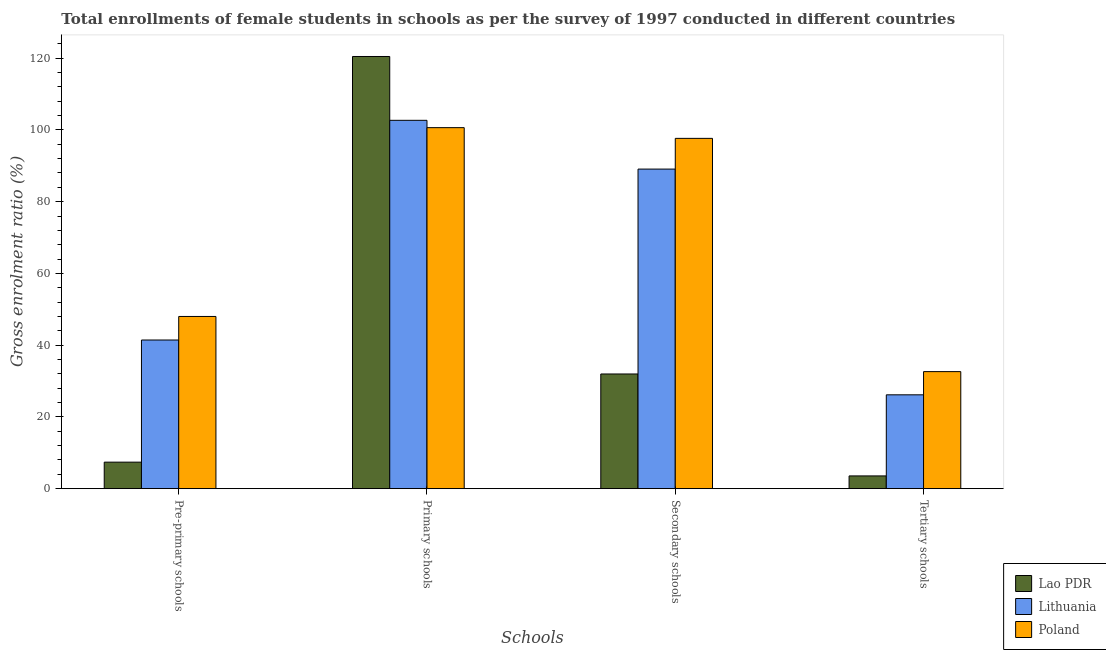How many bars are there on the 3rd tick from the left?
Give a very brief answer. 3. How many bars are there on the 2nd tick from the right?
Ensure brevity in your answer.  3. What is the label of the 1st group of bars from the left?
Your answer should be very brief. Pre-primary schools. What is the gross enrolment ratio(female) in primary schools in Lithuania?
Provide a short and direct response. 102.67. Across all countries, what is the maximum gross enrolment ratio(female) in primary schools?
Your answer should be compact. 120.47. Across all countries, what is the minimum gross enrolment ratio(female) in tertiary schools?
Make the answer very short. 3.56. In which country was the gross enrolment ratio(female) in pre-primary schools minimum?
Give a very brief answer. Lao PDR. What is the total gross enrolment ratio(female) in secondary schools in the graph?
Your answer should be very brief. 218.7. What is the difference between the gross enrolment ratio(female) in primary schools in Lithuania and that in Lao PDR?
Make the answer very short. -17.79. What is the difference between the gross enrolment ratio(female) in tertiary schools in Lithuania and the gross enrolment ratio(female) in pre-primary schools in Lao PDR?
Provide a short and direct response. 18.77. What is the average gross enrolment ratio(female) in tertiary schools per country?
Make the answer very short. 20.78. What is the difference between the gross enrolment ratio(female) in tertiary schools and gross enrolment ratio(female) in primary schools in Lao PDR?
Give a very brief answer. -116.91. What is the ratio of the gross enrolment ratio(female) in tertiary schools in Lao PDR to that in Lithuania?
Provide a short and direct response. 0.14. Is the gross enrolment ratio(female) in pre-primary schools in Poland less than that in Lao PDR?
Make the answer very short. No. What is the difference between the highest and the second highest gross enrolment ratio(female) in secondary schools?
Your answer should be very brief. 8.56. What is the difference between the highest and the lowest gross enrolment ratio(female) in pre-primary schools?
Your answer should be compact. 40.61. In how many countries, is the gross enrolment ratio(female) in pre-primary schools greater than the average gross enrolment ratio(female) in pre-primary schools taken over all countries?
Your response must be concise. 2. Is it the case that in every country, the sum of the gross enrolment ratio(female) in primary schools and gross enrolment ratio(female) in tertiary schools is greater than the sum of gross enrolment ratio(female) in secondary schools and gross enrolment ratio(female) in pre-primary schools?
Keep it short and to the point. Yes. What does the 2nd bar from the left in Secondary schools represents?
Your answer should be compact. Lithuania. What does the 2nd bar from the right in Secondary schools represents?
Your response must be concise. Lithuania. Are all the bars in the graph horizontal?
Your answer should be compact. No. How many countries are there in the graph?
Provide a short and direct response. 3. What is the difference between two consecutive major ticks on the Y-axis?
Ensure brevity in your answer.  20. Does the graph contain grids?
Your answer should be very brief. No. What is the title of the graph?
Provide a short and direct response. Total enrollments of female students in schools as per the survey of 1997 conducted in different countries. What is the label or title of the X-axis?
Provide a short and direct response. Schools. What is the label or title of the Y-axis?
Offer a terse response. Gross enrolment ratio (%). What is the Gross enrolment ratio (%) in Lao PDR in Pre-primary schools?
Make the answer very short. 7.39. What is the Gross enrolment ratio (%) of Lithuania in Pre-primary schools?
Give a very brief answer. 41.44. What is the Gross enrolment ratio (%) of Poland in Pre-primary schools?
Offer a terse response. 48. What is the Gross enrolment ratio (%) of Lao PDR in Primary schools?
Your answer should be very brief. 120.47. What is the Gross enrolment ratio (%) in Lithuania in Primary schools?
Provide a succinct answer. 102.67. What is the Gross enrolment ratio (%) in Poland in Primary schools?
Offer a terse response. 100.63. What is the Gross enrolment ratio (%) of Lao PDR in Secondary schools?
Keep it short and to the point. 31.97. What is the Gross enrolment ratio (%) in Lithuania in Secondary schools?
Provide a short and direct response. 89.08. What is the Gross enrolment ratio (%) of Poland in Secondary schools?
Give a very brief answer. 97.65. What is the Gross enrolment ratio (%) in Lao PDR in Tertiary schools?
Your answer should be compact. 3.56. What is the Gross enrolment ratio (%) in Lithuania in Tertiary schools?
Make the answer very short. 26.16. What is the Gross enrolment ratio (%) in Poland in Tertiary schools?
Your answer should be compact. 32.63. Across all Schools, what is the maximum Gross enrolment ratio (%) in Lao PDR?
Keep it short and to the point. 120.47. Across all Schools, what is the maximum Gross enrolment ratio (%) in Lithuania?
Provide a short and direct response. 102.67. Across all Schools, what is the maximum Gross enrolment ratio (%) of Poland?
Your answer should be very brief. 100.63. Across all Schools, what is the minimum Gross enrolment ratio (%) in Lao PDR?
Ensure brevity in your answer.  3.56. Across all Schools, what is the minimum Gross enrolment ratio (%) of Lithuania?
Your answer should be compact. 26.16. Across all Schools, what is the minimum Gross enrolment ratio (%) of Poland?
Your response must be concise. 32.63. What is the total Gross enrolment ratio (%) in Lao PDR in the graph?
Provide a succinct answer. 163.39. What is the total Gross enrolment ratio (%) of Lithuania in the graph?
Provide a succinct answer. 259.36. What is the total Gross enrolment ratio (%) in Poland in the graph?
Offer a terse response. 278.91. What is the difference between the Gross enrolment ratio (%) of Lao PDR in Pre-primary schools and that in Primary schools?
Make the answer very short. -113.08. What is the difference between the Gross enrolment ratio (%) of Lithuania in Pre-primary schools and that in Primary schools?
Keep it short and to the point. -61.23. What is the difference between the Gross enrolment ratio (%) in Poland in Pre-primary schools and that in Primary schools?
Provide a short and direct response. -52.63. What is the difference between the Gross enrolment ratio (%) in Lao PDR in Pre-primary schools and that in Secondary schools?
Your response must be concise. -24.58. What is the difference between the Gross enrolment ratio (%) in Lithuania in Pre-primary schools and that in Secondary schools?
Offer a terse response. -47.64. What is the difference between the Gross enrolment ratio (%) of Poland in Pre-primary schools and that in Secondary schools?
Offer a terse response. -49.64. What is the difference between the Gross enrolment ratio (%) in Lao PDR in Pre-primary schools and that in Tertiary schools?
Your answer should be very brief. 3.84. What is the difference between the Gross enrolment ratio (%) in Lithuania in Pre-primary schools and that in Tertiary schools?
Offer a very short reply. 15.28. What is the difference between the Gross enrolment ratio (%) of Poland in Pre-primary schools and that in Tertiary schools?
Make the answer very short. 15.37. What is the difference between the Gross enrolment ratio (%) in Lao PDR in Primary schools and that in Secondary schools?
Your response must be concise. 88.5. What is the difference between the Gross enrolment ratio (%) in Lithuania in Primary schools and that in Secondary schools?
Make the answer very short. 13.59. What is the difference between the Gross enrolment ratio (%) of Poland in Primary schools and that in Secondary schools?
Ensure brevity in your answer.  2.98. What is the difference between the Gross enrolment ratio (%) in Lao PDR in Primary schools and that in Tertiary schools?
Provide a succinct answer. 116.91. What is the difference between the Gross enrolment ratio (%) of Lithuania in Primary schools and that in Tertiary schools?
Make the answer very short. 76.51. What is the difference between the Gross enrolment ratio (%) in Poland in Primary schools and that in Tertiary schools?
Your response must be concise. 68. What is the difference between the Gross enrolment ratio (%) in Lao PDR in Secondary schools and that in Tertiary schools?
Provide a short and direct response. 28.42. What is the difference between the Gross enrolment ratio (%) of Lithuania in Secondary schools and that in Tertiary schools?
Your answer should be very brief. 62.92. What is the difference between the Gross enrolment ratio (%) in Poland in Secondary schools and that in Tertiary schools?
Keep it short and to the point. 65.02. What is the difference between the Gross enrolment ratio (%) in Lao PDR in Pre-primary schools and the Gross enrolment ratio (%) in Lithuania in Primary schools?
Your answer should be compact. -95.28. What is the difference between the Gross enrolment ratio (%) in Lao PDR in Pre-primary schools and the Gross enrolment ratio (%) in Poland in Primary schools?
Make the answer very short. -93.24. What is the difference between the Gross enrolment ratio (%) in Lithuania in Pre-primary schools and the Gross enrolment ratio (%) in Poland in Primary schools?
Your response must be concise. -59.19. What is the difference between the Gross enrolment ratio (%) of Lao PDR in Pre-primary schools and the Gross enrolment ratio (%) of Lithuania in Secondary schools?
Your answer should be compact. -81.69. What is the difference between the Gross enrolment ratio (%) in Lao PDR in Pre-primary schools and the Gross enrolment ratio (%) in Poland in Secondary schools?
Ensure brevity in your answer.  -90.25. What is the difference between the Gross enrolment ratio (%) in Lithuania in Pre-primary schools and the Gross enrolment ratio (%) in Poland in Secondary schools?
Give a very brief answer. -56.21. What is the difference between the Gross enrolment ratio (%) in Lao PDR in Pre-primary schools and the Gross enrolment ratio (%) in Lithuania in Tertiary schools?
Ensure brevity in your answer.  -18.77. What is the difference between the Gross enrolment ratio (%) in Lao PDR in Pre-primary schools and the Gross enrolment ratio (%) in Poland in Tertiary schools?
Offer a very short reply. -25.24. What is the difference between the Gross enrolment ratio (%) in Lithuania in Pre-primary schools and the Gross enrolment ratio (%) in Poland in Tertiary schools?
Ensure brevity in your answer.  8.81. What is the difference between the Gross enrolment ratio (%) of Lao PDR in Primary schools and the Gross enrolment ratio (%) of Lithuania in Secondary schools?
Your response must be concise. 31.39. What is the difference between the Gross enrolment ratio (%) of Lao PDR in Primary schools and the Gross enrolment ratio (%) of Poland in Secondary schools?
Give a very brief answer. 22.82. What is the difference between the Gross enrolment ratio (%) of Lithuania in Primary schools and the Gross enrolment ratio (%) of Poland in Secondary schools?
Provide a short and direct response. 5.03. What is the difference between the Gross enrolment ratio (%) in Lao PDR in Primary schools and the Gross enrolment ratio (%) in Lithuania in Tertiary schools?
Ensure brevity in your answer.  94.31. What is the difference between the Gross enrolment ratio (%) of Lao PDR in Primary schools and the Gross enrolment ratio (%) of Poland in Tertiary schools?
Offer a terse response. 87.84. What is the difference between the Gross enrolment ratio (%) of Lithuania in Primary schools and the Gross enrolment ratio (%) of Poland in Tertiary schools?
Ensure brevity in your answer.  70.04. What is the difference between the Gross enrolment ratio (%) of Lao PDR in Secondary schools and the Gross enrolment ratio (%) of Lithuania in Tertiary schools?
Offer a terse response. 5.81. What is the difference between the Gross enrolment ratio (%) in Lao PDR in Secondary schools and the Gross enrolment ratio (%) in Poland in Tertiary schools?
Your response must be concise. -0.66. What is the difference between the Gross enrolment ratio (%) in Lithuania in Secondary schools and the Gross enrolment ratio (%) in Poland in Tertiary schools?
Keep it short and to the point. 56.45. What is the average Gross enrolment ratio (%) of Lao PDR per Schools?
Give a very brief answer. 40.85. What is the average Gross enrolment ratio (%) of Lithuania per Schools?
Give a very brief answer. 64.84. What is the average Gross enrolment ratio (%) of Poland per Schools?
Your answer should be very brief. 69.73. What is the difference between the Gross enrolment ratio (%) in Lao PDR and Gross enrolment ratio (%) in Lithuania in Pre-primary schools?
Provide a succinct answer. -34.05. What is the difference between the Gross enrolment ratio (%) of Lao PDR and Gross enrolment ratio (%) of Poland in Pre-primary schools?
Make the answer very short. -40.61. What is the difference between the Gross enrolment ratio (%) in Lithuania and Gross enrolment ratio (%) in Poland in Pre-primary schools?
Make the answer very short. -6.56. What is the difference between the Gross enrolment ratio (%) of Lao PDR and Gross enrolment ratio (%) of Lithuania in Primary schools?
Make the answer very short. 17.8. What is the difference between the Gross enrolment ratio (%) of Lao PDR and Gross enrolment ratio (%) of Poland in Primary schools?
Offer a terse response. 19.84. What is the difference between the Gross enrolment ratio (%) of Lithuania and Gross enrolment ratio (%) of Poland in Primary schools?
Provide a short and direct response. 2.04. What is the difference between the Gross enrolment ratio (%) in Lao PDR and Gross enrolment ratio (%) in Lithuania in Secondary schools?
Your answer should be compact. -57.11. What is the difference between the Gross enrolment ratio (%) of Lao PDR and Gross enrolment ratio (%) of Poland in Secondary schools?
Your response must be concise. -65.68. What is the difference between the Gross enrolment ratio (%) in Lithuania and Gross enrolment ratio (%) in Poland in Secondary schools?
Ensure brevity in your answer.  -8.56. What is the difference between the Gross enrolment ratio (%) of Lao PDR and Gross enrolment ratio (%) of Lithuania in Tertiary schools?
Make the answer very short. -22.61. What is the difference between the Gross enrolment ratio (%) of Lao PDR and Gross enrolment ratio (%) of Poland in Tertiary schools?
Ensure brevity in your answer.  -29.08. What is the difference between the Gross enrolment ratio (%) in Lithuania and Gross enrolment ratio (%) in Poland in Tertiary schools?
Provide a short and direct response. -6.47. What is the ratio of the Gross enrolment ratio (%) of Lao PDR in Pre-primary schools to that in Primary schools?
Provide a succinct answer. 0.06. What is the ratio of the Gross enrolment ratio (%) of Lithuania in Pre-primary schools to that in Primary schools?
Give a very brief answer. 0.4. What is the ratio of the Gross enrolment ratio (%) in Poland in Pre-primary schools to that in Primary schools?
Your answer should be very brief. 0.48. What is the ratio of the Gross enrolment ratio (%) of Lao PDR in Pre-primary schools to that in Secondary schools?
Provide a succinct answer. 0.23. What is the ratio of the Gross enrolment ratio (%) of Lithuania in Pre-primary schools to that in Secondary schools?
Make the answer very short. 0.47. What is the ratio of the Gross enrolment ratio (%) in Poland in Pre-primary schools to that in Secondary schools?
Your answer should be very brief. 0.49. What is the ratio of the Gross enrolment ratio (%) in Lao PDR in Pre-primary schools to that in Tertiary schools?
Offer a very short reply. 2.08. What is the ratio of the Gross enrolment ratio (%) in Lithuania in Pre-primary schools to that in Tertiary schools?
Offer a very short reply. 1.58. What is the ratio of the Gross enrolment ratio (%) in Poland in Pre-primary schools to that in Tertiary schools?
Offer a terse response. 1.47. What is the ratio of the Gross enrolment ratio (%) of Lao PDR in Primary schools to that in Secondary schools?
Your answer should be very brief. 3.77. What is the ratio of the Gross enrolment ratio (%) of Lithuania in Primary schools to that in Secondary schools?
Give a very brief answer. 1.15. What is the ratio of the Gross enrolment ratio (%) in Poland in Primary schools to that in Secondary schools?
Provide a short and direct response. 1.03. What is the ratio of the Gross enrolment ratio (%) of Lao PDR in Primary schools to that in Tertiary schools?
Provide a succinct answer. 33.88. What is the ratio of the Gross enrolment ratio (%) of Lithuania in Primary schools to that in Tertiary schools?
Your answer should be compact. 3.92. What is the ratio of the Gross enrolment ratio (%) in Poland in Primary schools to that in Tertiary schools?
Provide a short and direct response. 3.08. What is the ratio of the Gross enrolment ratio (%) in Lao PDR in Secondary schools to that in Tertiary schools?
Provide a short and direct response. 8.99. What is the ratio of the Gross enrolment ratio (%) in Lithuania in Secondary schools to that in Tertiary schools?
Your response must be concise. 3.4. What is the ratio of the Gross enrolment ratio (%) in Poland in Secondary schools to that in Tertiary schools?
Your response must be concise. 2.99. What is the difference between the highest and the second highest Gross enrolment ratio (%) of Lao PDR?
Keep it short and to the point. 88.5. What is the difference between the highest and the second highest Gross enrolment ratio (%) of Lithuania?
Make the answer very short. 13.59. What is the difference between the highest and the second highest Gross enrolment ratio (%) in Poland?
Keep it short and to the point. 2.98. What is the difference between the highest and the lowest Gross enrolment ratio (%) of Lao PDR?
Give a very brief answer. 116.91. What is the difference between the highest and the lowest Gross enrolment ratio (%) of Lithuania?
Provide a succinct answer. 76.51. What is the difference between the highest and the lowest Gross enrolment ratio (%) of Poland?
Your response must be concise. 68. 